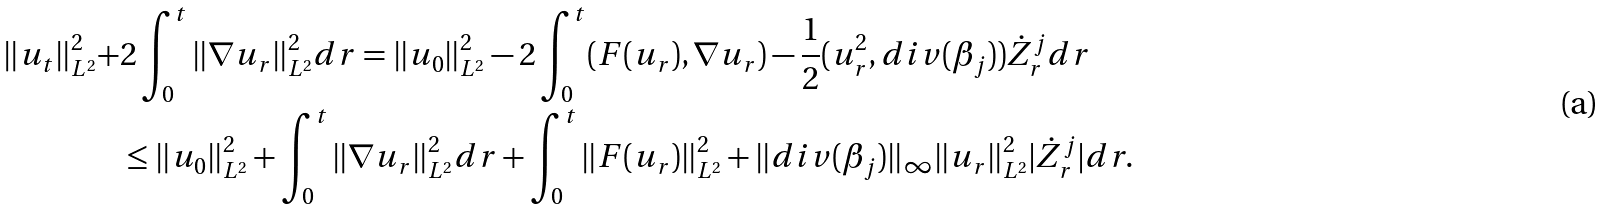<formula> <loc_0><loc_0><loc_500><loc_500>\| u _ { t } \| _ { L ^ { 2 } } ^ { 2 } + & 2 \int _ { 0 } ^ { t } \| \nabla u _ { r } \| ^ { 2 } _ { L ^ { 2 } } d r = \| u _ { 0 } \| _ { L ^ { 2 } } ^ { 2 } - 2 \int _ { 0 } ^ { t } ( F ( u _ { r } ) , \nabla u _ { r } ) - \frac { 1 } { 2 } ( u _ { r } ^ { 2 } , d i v ( \beta _ { j } ) ) \dot { Z } _ { r } ^ { j } d r \\ & \leq \| u _ { 0 } \| _ { L ^ { 2 } } ^ { 2 } + \int _ { 0 } ^ { t } \| \nabla u _ { r } \| ^ { 2 } _ { L ^ { 2 } } d r + \int _ { 0 } ^ { t } \| F ( u _ { r } ) \| _ { L ^ { 2 } } ^ { 2 } + \| d i v ( \beta _ { j } ) \| _ { \infty } \| u _ { r } \| _ { L ^ { 2 } } ^ { 2 } | \dot { Z } _ { r } ^ { j } | d r .</formula> 